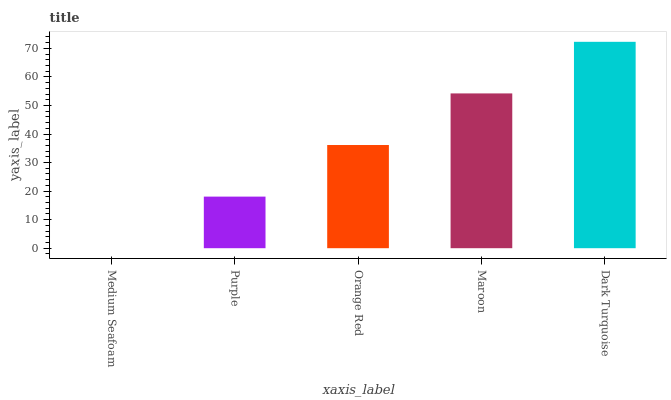Is Medium Seafoam the minimum?
Answer yes or no. Yes. Is Dark Turquoise the maximum?
Answer yes or no. Yes. Is Purple the minimum?
Answer yes or no. No. Is Purple the maximum?
Answer yes or no. No. Is Purple greater than Medium Seafoam?
Answer yes or no. Yes. Is Medium Seafoam less than Purple?
Answer yes or no. Yes. Is Medium Seafoam greater than Purple?
Answer yes or no. No. Is Purple less than Medium Seafoam?
Answer yes or no. No. Is Orange Red the high median?
Answer yes or no. Yes. Is Orange Red the low median?
Answer yes or no. Yes. Is Dark Turquoise the high median?
Answer yes or no. No. Is Purple the low median?
Answer yes or no. No. 